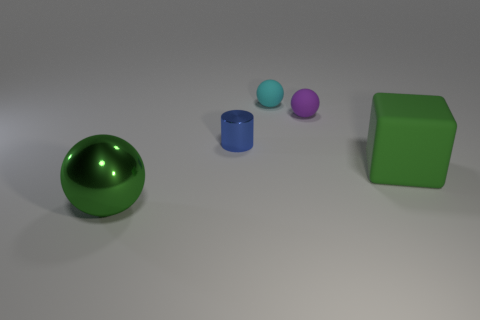Add 3 purple matte things. How many objects exist? 8 Subtract all spheres. How many objects are left? 2 Subtract all rubber cylinders. Subtract all large blocks. How many objects are left? 4 Add 1 tiny purple rubber balls. How many tiny purple rubber balls are left? 2 Add 4 red rubber cylinders. How many red rubber cylinders exist? 4 Subtract 0 blue balls. How many objects are left? 5 